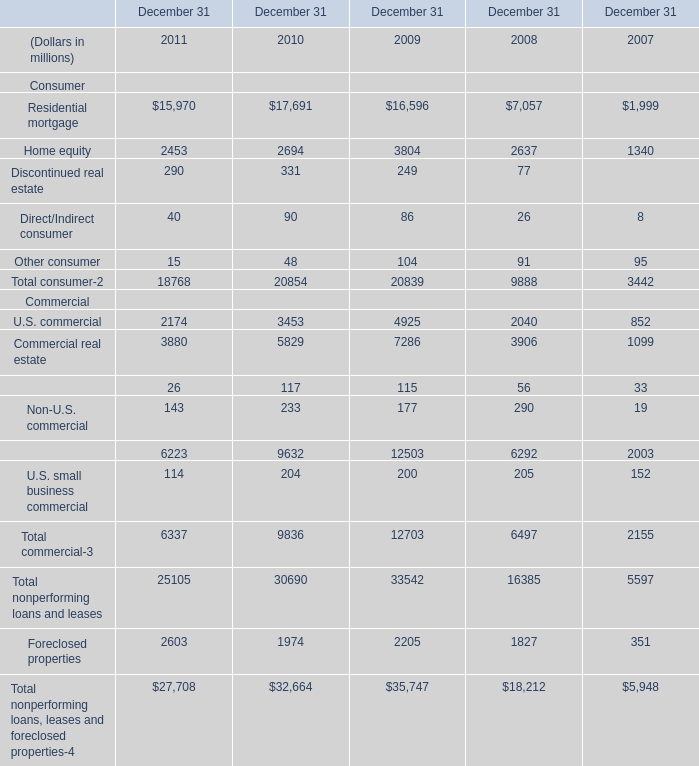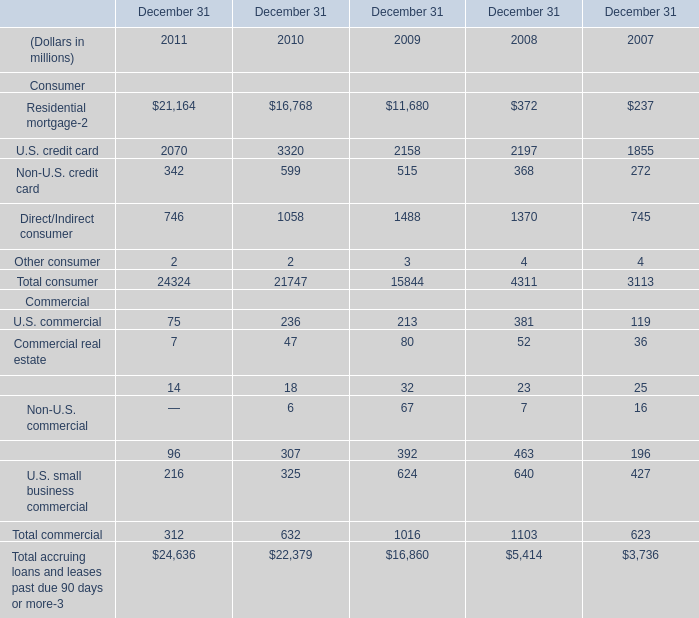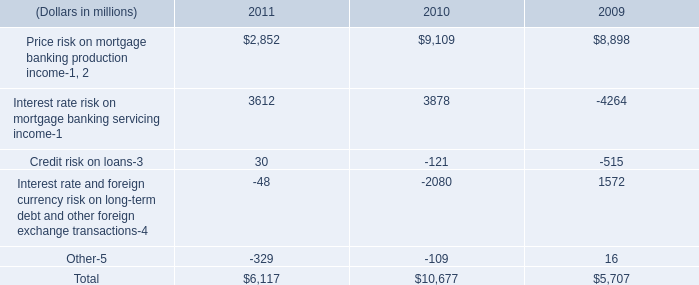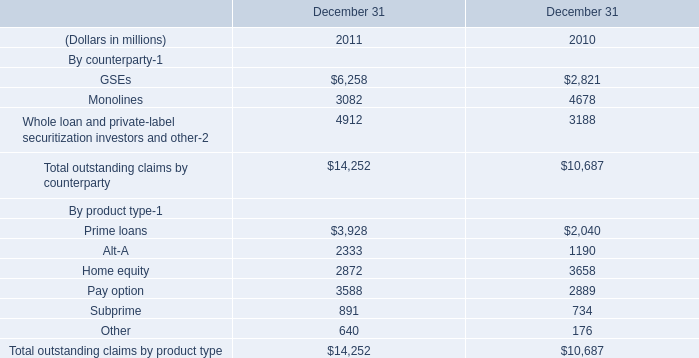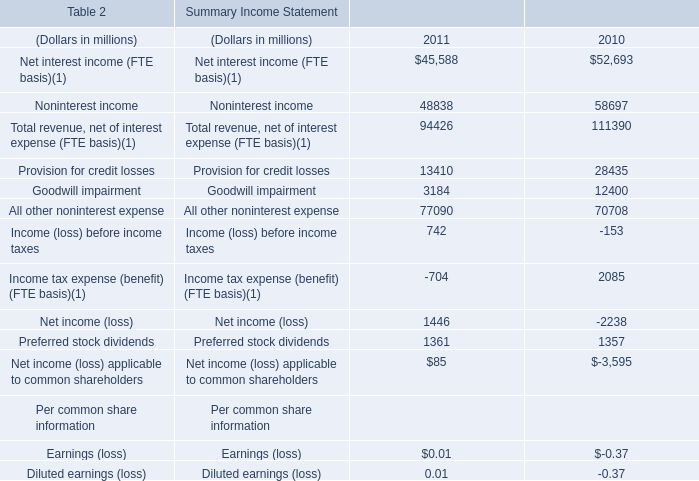what's the total amount of Home equity of December 31 2010, Prime loans By product type of December 31 2010, and Total commercial Commercial of December 31 2008 ? 
Computations: ((2694.0 + 2040.0) + 6497.0)
Answer: 11231.0. 